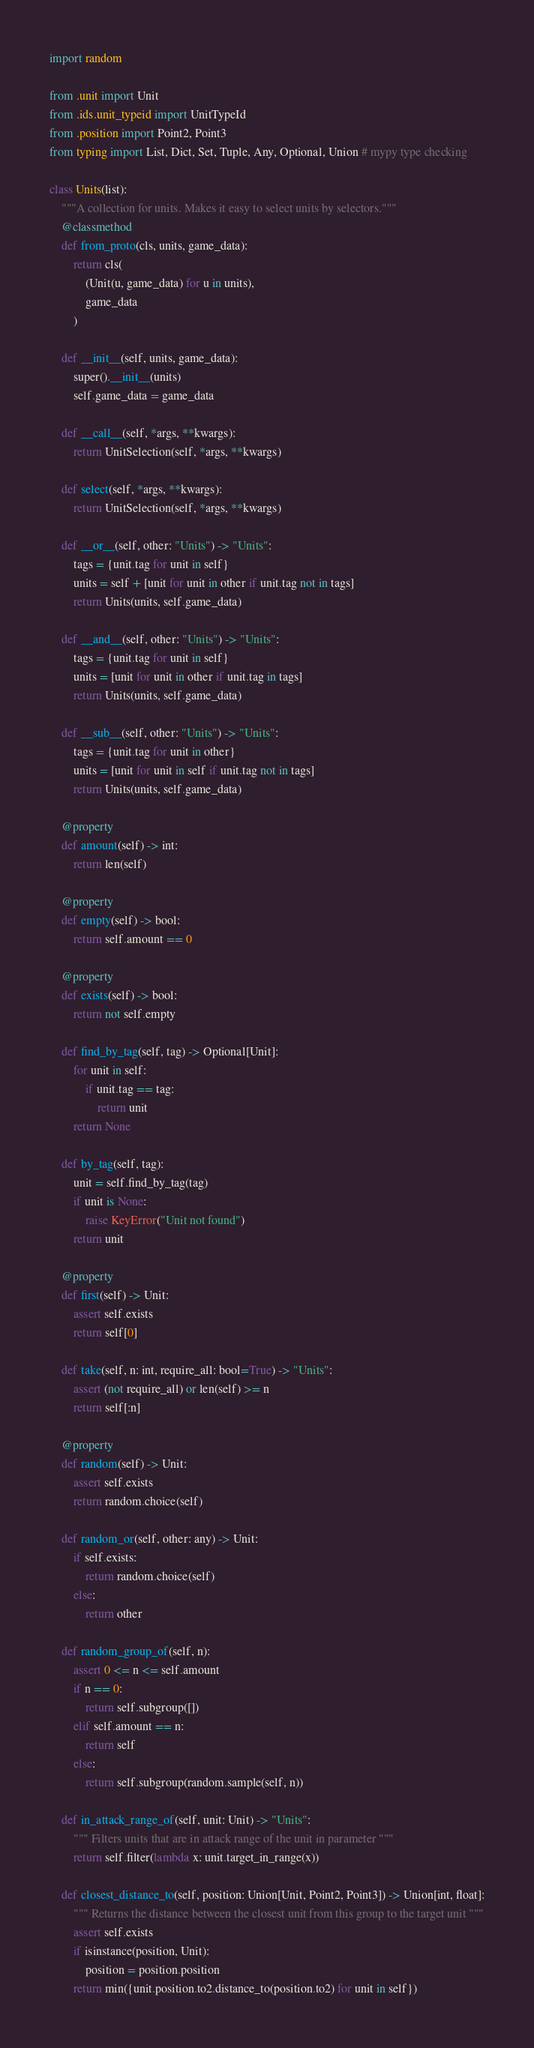<code> <loc_0><loc_0><loc_500><loc_500><_Python_>import random

from .unit import Unit
from .ids.unit_typeid import UnitTypeId
from .position import Point2, Point3
from typing import List, Dict, Set, Tuple, Any, Optional, Union # mypy type checking

class Units(list):
    """A collection for units. Makes it easy to select units by selectors."""
    @classmethod
    def from_proto(cls, units, game_data):
        return cls(
            (Unit(u, game_data) for u in units),
            game_data
        )

    def __init__(self, units, game_data):
        super().__init__(units)
        self.game_data = game_data

    def __call__(self, *args, **kwargs):
        return UnitSelection(self, *args, **kwargs)

    def select(self, *args, **kwargs):
        return UnitSelection(self, *args, **kwargs)

    def __or__(self, other: "Units") -> "Units":
        tags = {unit.tag for unit in self}
        units = self + [unit for unit in other if unit.tag not in tags]
        return Units(units, self.game_data)

    def __and__(self, other: "Units") -> "Units":
        tags = {unit.tag for unit in self}
        units = [unit for unit in other if unit.tag in tags]
        return Units(units, self.game_data)

    def __sub__(self, other: "Units") -> "Units":
        tags = {unit.tag for unit in other}
        units = [unit for unit in self if unit.tag not in tags]
        return Units(units, self.game_data)

    @property
    def amount(self) -> int:
        return len(self)

    @property
    def empty(self) -> bool:
        return self.amount == 0

    @property
    def exists(self) -> bool:
        return not self.empty

    def find_by_tag(self, tag) -> Optional[Unit]:
        for unit in self:
            if unit.tag == tag:
                return unit
        return None

    def by_tag(self, tag):
        unit = self.find_by_tag(tag)
        if unit is None:
            raise KeyError("Unit not found")
        return unit

    @property
    def first(self) -> Unit:
        assert self.exists
        return self[0]

    def take(self, n: int, require_all: bool=True) -> "Units":
        assert (not require_all) or len(self) >= n
        return self[:n]

    @property
    def random(self) -> Unit:
        assert self.exists
        return random.choice(self)

    def random_or(self, other: any) -> Unit:
        if self.exists:
            return random.choice(self)
        else:
            return other

    def random_group_of(self, n):
        assert 0 <= n <= self.amount
        if n == 0:
            return self.subgroup([])
        elif self.amount == n:
            return self
        else:
            return self.subgroup(random.sample(self, n))

    def in_attack_range_of(self, unit: Unit) -> "Units":
        """ Filters units that are in attack range of the unit in parameter """
        return self.filter(lambda x: unit.target_in_range(x))

    def closest_distance_to(self, position: Union[Unit, Point2, Point3]) -> Union[int, float]:
        """ Returns the distance between the closest unit from this group to the target unit """
        assert self.exists
        if isinstance(position, Unit):
            position = position.position
        return min({unit.position.to2.distance_to(position.to2) for unit in self})
</code> 